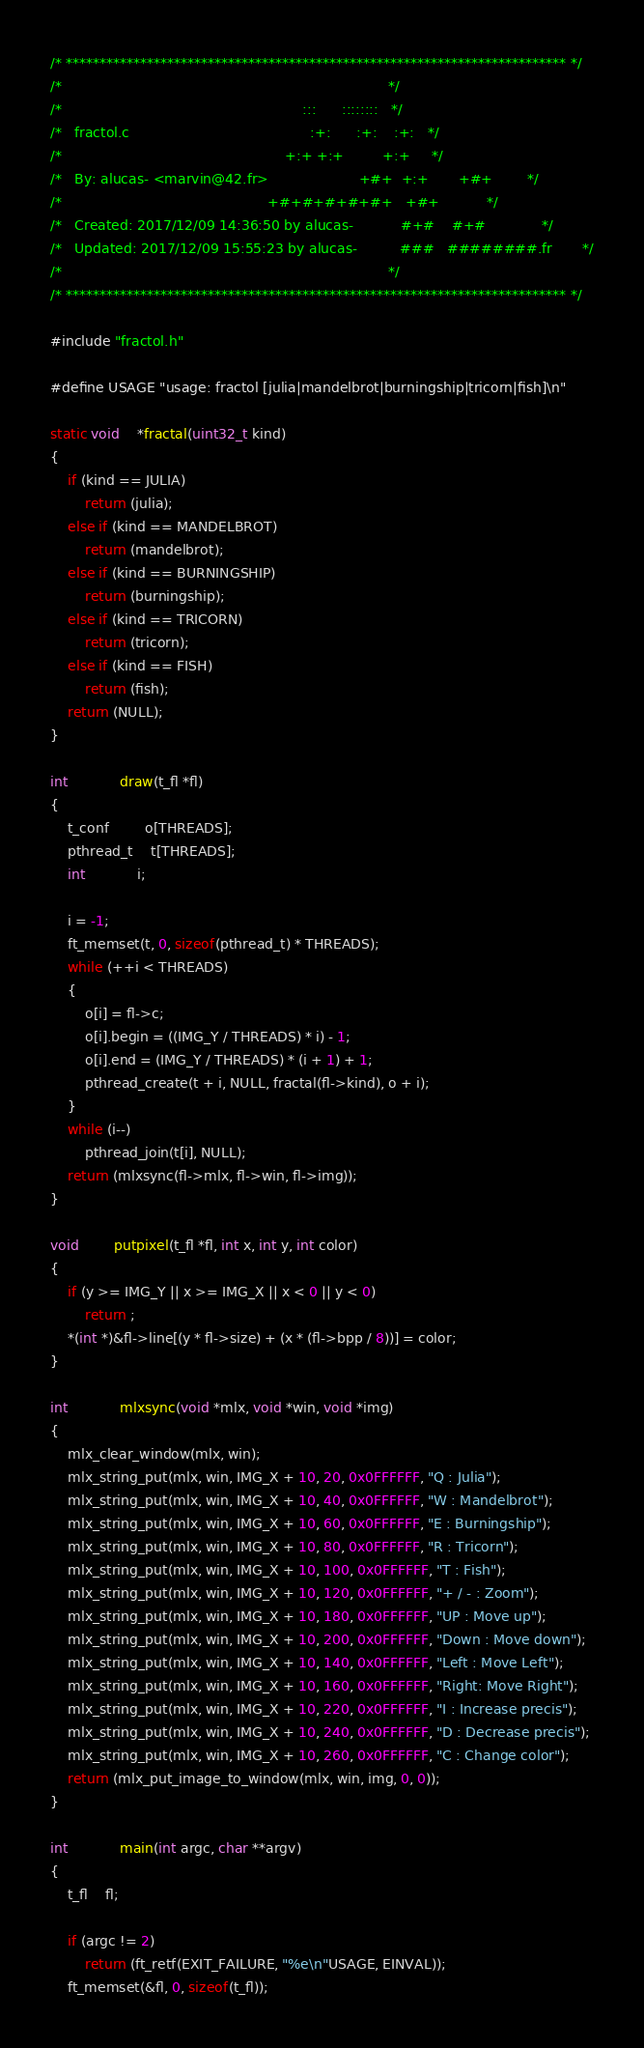Convert code to text. <code><loc_0><loc_0><loc_500><loc_500><_C_>/* ************************************************************************** */
/*                                                                            */
/*                                                        :::      ::::::::   */
/*   fractol.c                                          :+:      :+:    :+:   */
/*                                                    +:+ +:+         +:+     */
/*   By: alucas- <marvin@42.fr>                     +#+  +:+       +#+        */
/*                                                +#+#+#+#+#+   +#+           */
/*   Created: 2017/12/09 14:36:50 by alucas-           #+#    #+#             */
/*   Updated: 2017/12/09 15:55:23 by alucas-          ###   ########.fr       */
/*                                                                            */
/* ************************************************************************** */

#include "fractol.h"

#define USAGE "usage: fractol [julia|mandelbrot|burningship|tricorn|fish]\n"

static void	*fractal(uint32_t kind)
{
	if (kind == JULIA)
		return (julia);
	else if (kind == MANDELBROT)
		return (mandelbrot);
	else if (kind == BURNINGSHIP)
		return (burningship);
	else if (kind == TRICORN)
		return (tricorn);
	else if (kind == FISH)
		return (fish);
	return (NULL);
}

int			draw(t_fl *fl)
{
	t_conf		o[THREADS];
	pthread_t	t[THREADS];
	int			i;

	i = -1;
	ft_memset(t, 0, sizeof(pthread_t) * THREADS);
	while (++i < THREADS)
	{
		o[i] = fl->c;
		o[i].begin = ((IMG_Y / THREADS) * i) - 1;
		o[i].end = (IMG_Y / THREADS) * (i + 1) + 1;
		pthread_create(t + i, NULL, fractal(fl->kind), o + i);
	}
	while (i--)
		pthread_join(t[i], NULL);
	return (mlxsync(fl->mlx, fl->win, fl->img));
}

void		putpixel(t_fl *fl, int x, int y, int color)
{
	if (y >= IMG_Y || x >= IMG_X || x < 0 || y < 0)
		return ;
	*(int *)&fl->line[(y * fl->size) + (x * (fl->bpp / 8))] = color;
}

int			mlxsync(void *mlx, void *win, void *img)
{
	mlx_clear_window(mlx, win);
	mlx_string_put(mlx, win, IMG_X + 10, 20, 0x0FFFFFF, "Q : Julia");
	mlx_string_put(mlx, win, IMG_X + 10, 40, 0x0FFFFFF, "W : Mandelbrot");
	mlx_string_put(mlx, win, IMG_X + 10, 60, 0x0FFFFFF, "E : Burningship");
	mlx_string_put(mlx, win, IMG_X + 10, 80, 0x0FFFFFF, "R : Tricorn");
	mlx_string_put(mlx, win, IMG_X + 10, 100, 0x0FFFFFF, "T : Fish");
	mlx_string_put(mlx, win, IMG_X + 10, 120, 0x0FFFFFF, "+ / - : Zoom");
	mlx_string_put(mlx, win, IMG_X + 10, 180, 0x0FFFFFF, "UP : Move up");
	mlx_string_put(mlx, win, IMG_X + 10, 200, 0x0FFFFFF, "Down : Move down");
	mlx_string_put(mlx, win, IMG_X + 10, 140, 0x0FFFFFF, "Left : Move Left");
	mlx_string_put(mlx, win, IMG_X + 10, 160, 0x0FFFFFF, "Right: Move Right");
	mlx_string_put(mlx, win, IMG_X + 10, 220, 0x0FFFFFF, "I : Increase precis");
	mlx_string_put(mlx, win, IMG_X + 10, 240, 0x0FFFFFF, "D : Decrease precis");
	mlx_string_put(mlx, win, IMG_X + 10, 260, 0x0FFFFFF, "C : Change color");
	return (mlx_put_image_to_window(mlx, win, img, 0, 0));
}

int			main(int argc, char **argv)
{
	t_fl	fl;

	if (argc != 2)
		return (ft_retf(EXIT_FAILURE, "%e\n"USAGE, EINVAL));
	ft_memset(&fl, 0, sizeof(t_fl));</code> 